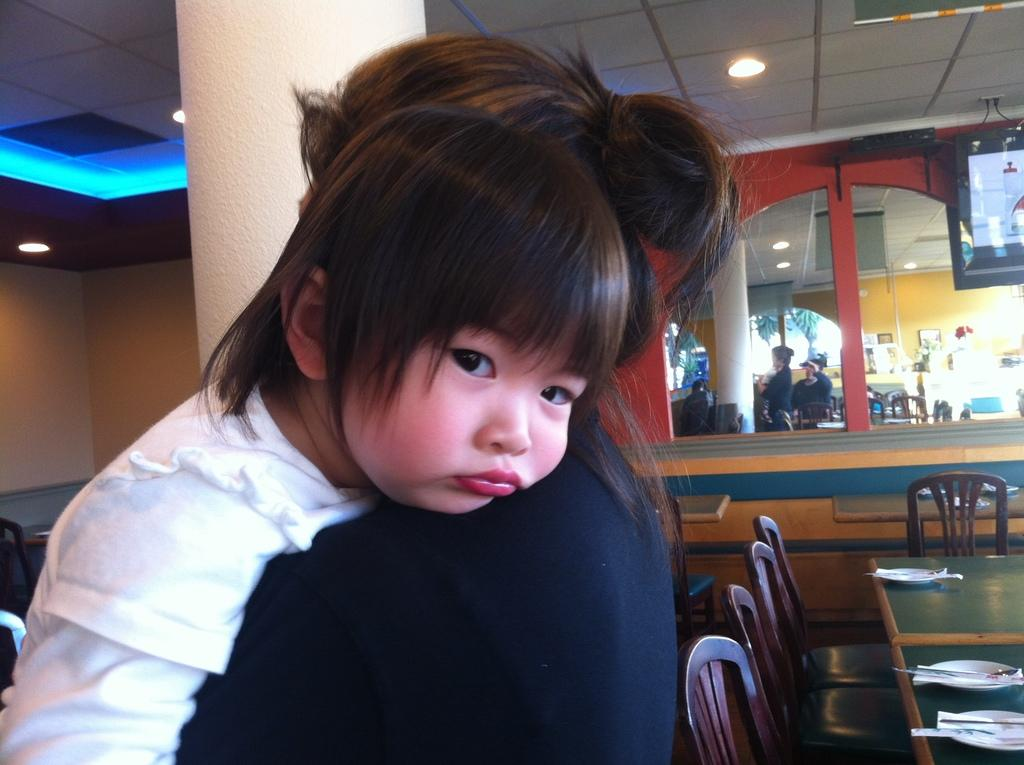Who is the main subject in the image? There is a woman in the image. What is the woman doing in the image? The woman is carrying a girl. What objects can be seen on a surface in the image? There are plates on a table in the image. What type of furniture is present in the image? There are chairs in the image. What type of bat can be seen flying in the image? There are no bats present in the image; it features a woman carrying a girl, plates on a table, and chairs. What type of invention is depicted in the image? There is no invention depicted in the image; it features a woman carrying a girl, plates on a table, and chairs. 